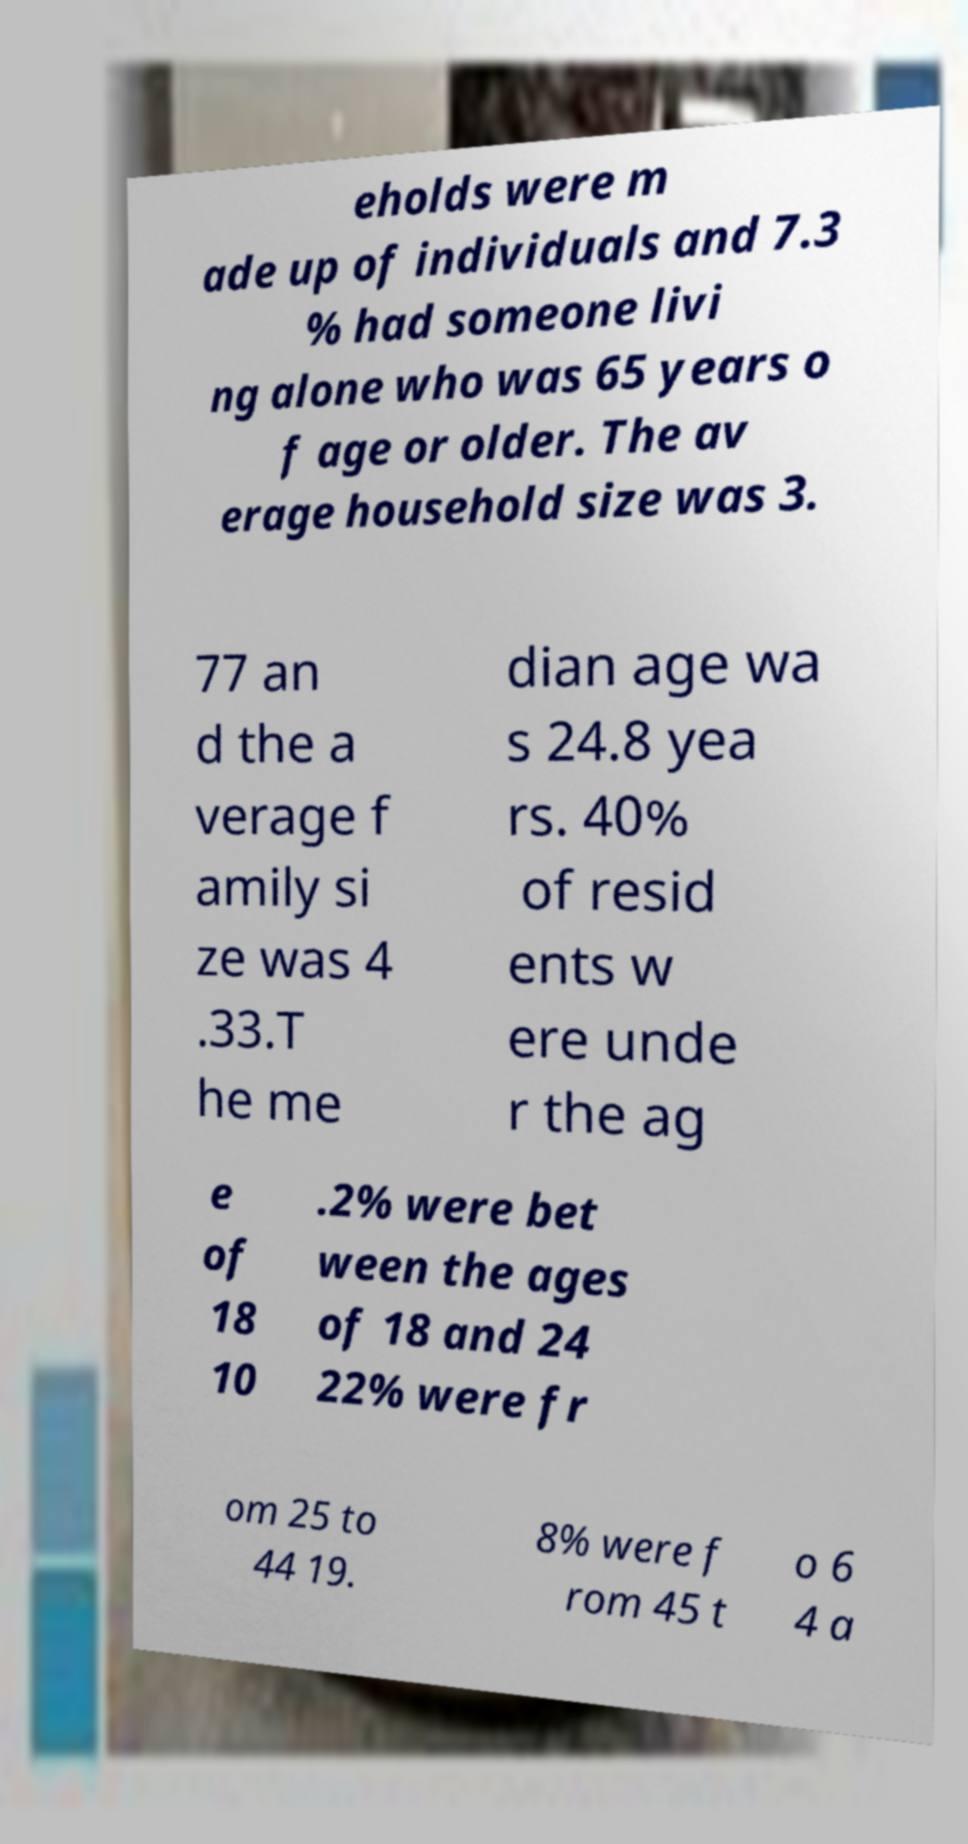Please identify and transcribe the text found in this image. eholds were m ade up of individuals and 7.3 % had someone livi ng alone who was 65 years o f age or older. The av erage household size was 3. 77 an d the a verage f amily si ze was 4 .33.T he me dian age wa s 24.8 yea rs. 40% of resid ents w ere unde r the ag e of 18 10 .2% were bet ween the ages of 18 and 24 22% were fr om 25 to 44 19. 8% were f rom 45 t o 6 4 a 